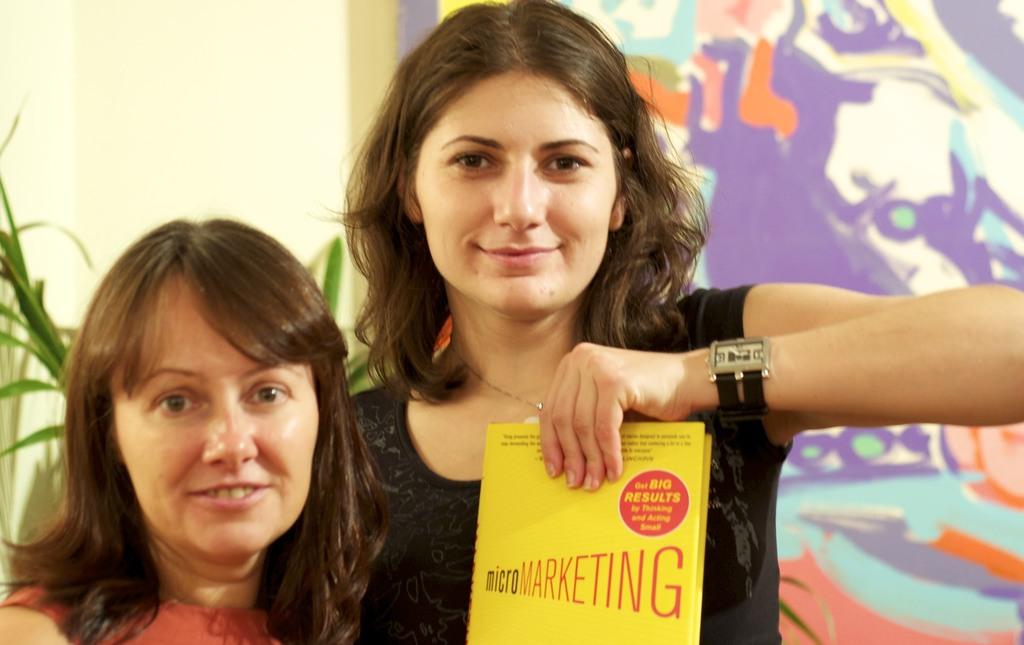What is the book title?
Your answer should be very brief. Micromarketing. 